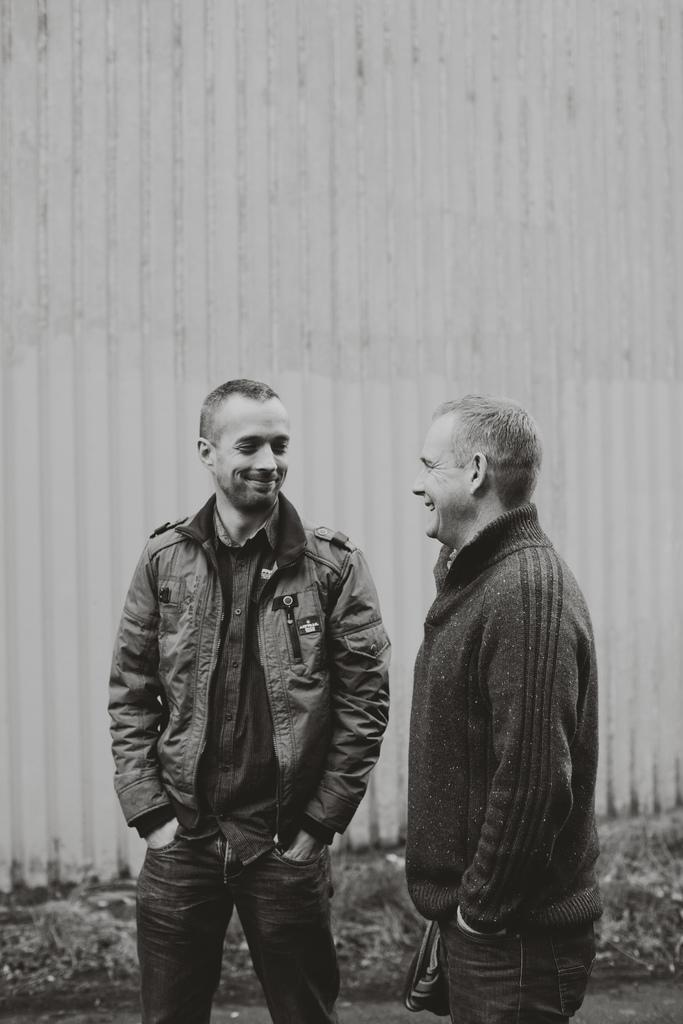What is the color scheme of the image? The image is black and white. How many people are in the image? There are two men in the image. What is the facial expression of the men in the image? The men are smiling. What can be seen in the background of the image? There is a wall in the background of the image. What type of pen is the man holding in the image? There is no pen visible in the image; the men are not holding any objects. Can you hear the horn in the image? There is no sound in the image, so it is not possible to hear a horn. 